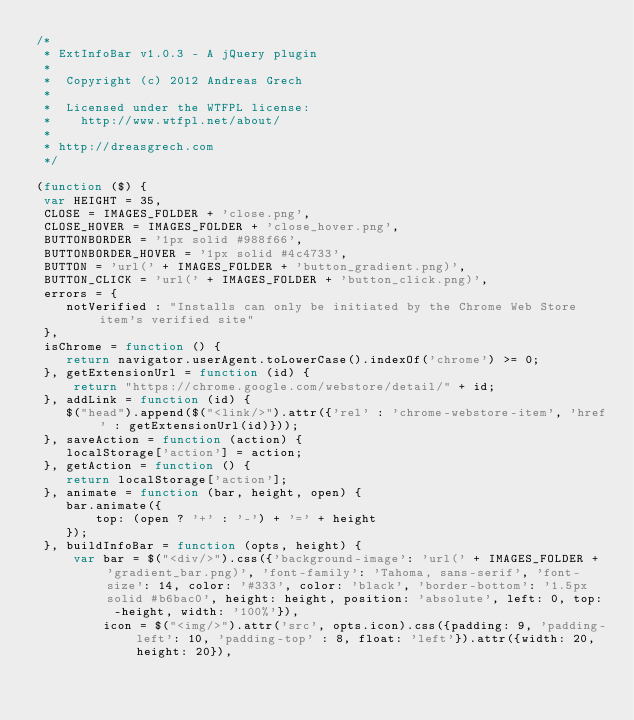<code> <loc_0><loc_0><loc_500><loc_500><_JavaScript_>/*
 * ExtInfoBar v1.0.3 - A jQuery plugin
 * 
 *  Copyright (c) 2012 Andreas Grech
 *
 *  Licensed under the WTFPL license:
 *    http://www.wtfpl.net/about/
 *
 * http://dreasgrech.com
 */

(function ($) {
 var HEIGHT = 35, 
 CLOSE = IMAGES_FOLDER + 'close.png',
 CLOSE_HOVER = IMAGES_FOLDER + 'close_hover.png',
 BUTTONBORDER = '1px solid #988f66',
 BUTTONBORDER_HOVER = '1px solid #4c4733',
 BUTTON = 'url(' + IMAGES_FOLDER + 'button_gradient.png)',
 BUTTON_CLICK = 'url(' + IMAGES_FOLDER + 'button_click.png)',
 errors = {
 	notVerified : "Installs can only be initiated by the Chrome Web Store item's verified site"
 },
 isChrome = function () {
	return navigator.userAgent.toLowerCase().indexOf('chrome') >= 0;
 }, getExtensionUrl = function (id) {
	 return "https://chrome.google.com/webstore/detail/" + id;
 }, addLink = function (id) {
 	$("head").append($("<link/>").attr({'rel' : 'chrome-webstore-item', 'href' : getExtensionUrl(id)}));
 }, saveAction = function (action) {
 	localStorage['action'] = action;
 }, getAction = function () {
 	return localStorage['action'];
 }, animate = function (bar, height, open) {
	bar.animate({
		top: (open ? '+' : '-') + '=' + height
	});
 }, buildInfoBar = function (opts, height) {
	 var bar = $("<div/>").css({'background-image': 'url(' + IMAGES_FOLDER + 'gradient_bar.png)', 'font-family': 'Tahoma, sans-serif', 'font-size': 14, color: '#333', color: 'black', 'border-bottom': '1.5px solid #b6bac0', height: height, position: 'absolute', left: 0, top: -height, width: '100%'}),
	     icon = $("<img/>").attr('src', opts.icon).css({padding: 9, 'padding-left': 10, 'padding-top' : 8, float: 'left'}).attr({width: 20, height: 20}),</code> 